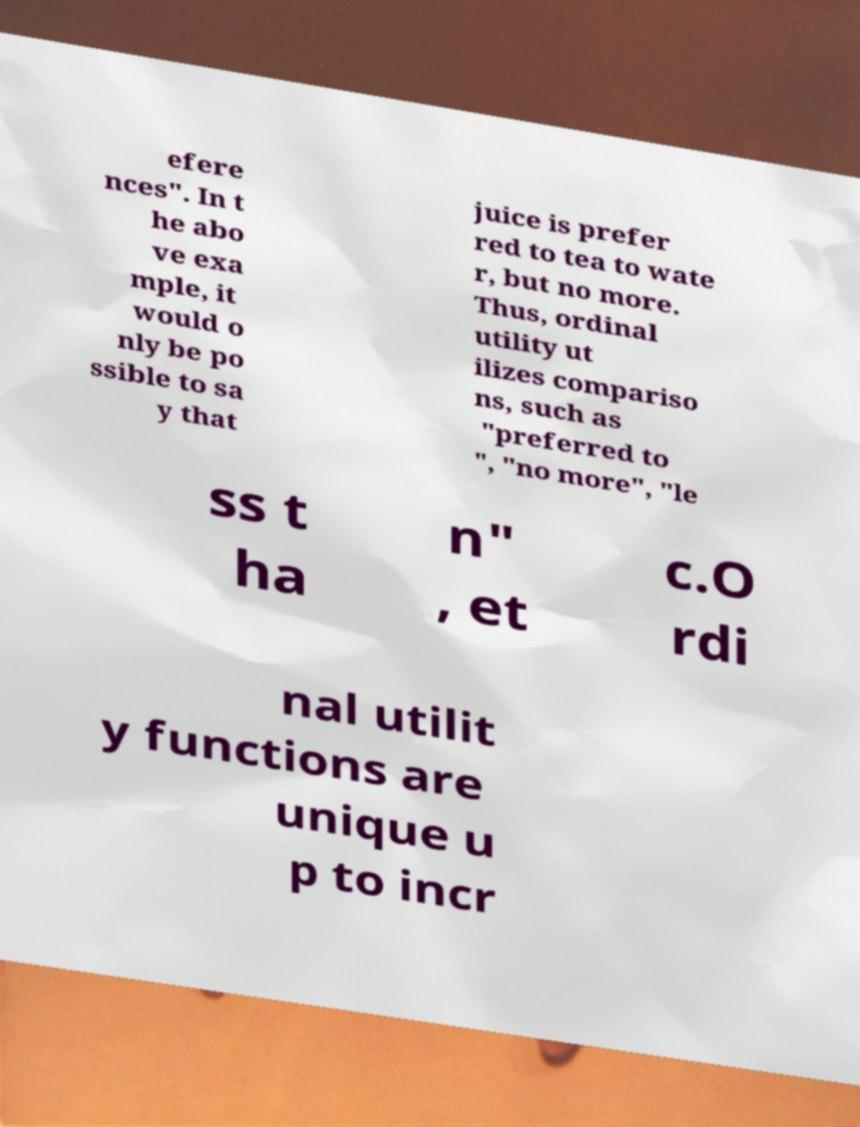Please read and relay the text visible in this image. What does it say? efere nces". In t he abo ve exa mple, it would o nly be po ssible to sa y that juice is prefer red to tea to wate r, but no more. Thus, ordinal utility ut ilizes compariso ns, such as "preferred to ", "no more", "le ss t ha n" , et c.O rdi nal utilit y functions are unique u p to incr 